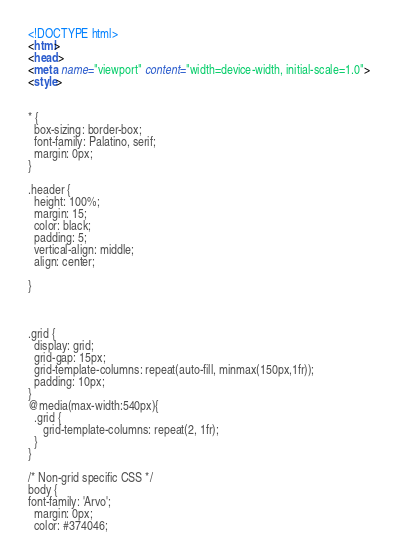<code> <loc_0><loc_0><loc_500><loc_500><_HTML_><!DOCTYPE html>
<html>
<head>
<meta name="viewport" content="width=device-width, initial-scale=1.0">
<style>


* {
  box-sizing: border-box;
  font-family: Palatino, serif;
  margin: 0px;
}

.header {
  height: 100%;
  margin: 15;
  color: black;
  padding: 5;
  vertical-align: middle;
  align: center;
  
}



.grid {
  display: grid;
  grid-gap: 15px;
  grid-template-columns: repeat(auto-fill, minmax(150px,1fr));
  padding: 10px;
}
@media(max-width:540px){
  .grid {
     grid-template-columns: repeat(2, 1fr);
  }
}

/* Non-grid specific CSS */  
body {
font-family: 'Arvo';
  margin: 0px;
  color: #374046;</code> 